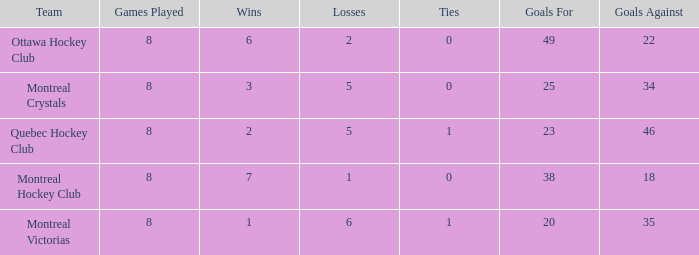Can you parse all the data within this table? {'header': ['Team', 'Games Played', 'Wins', 'Losses', 'Ties', 'Goals For', 'Goals Against'], 'rows': [['Ottawa Hockey Club', '8', '6', '2', '0', '49', '22'], ['Montreal Crystals', '8', '3', '5', '0', '25', '34'], ['Quebec Hockey Club', '8', '2', '5', '1', '23', '46'], ['Montreal Hockey Club', '8', '7', '1', '0', '38', '18'], ['Montreal Victorias', '8', '1', '6', '1', '20', '35']]} What is the total number of goals for when the ties is more than 0, the goals against is more than 35 and the wins is less than 2? 0.0. 